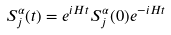Convert formula to latex. <formula><loc_0><loc_0><loc_500><loc_500>S ^ { \alpha } _ { j } ( t ) = e ^ { i H t } S ^ { \alpha } _ { j } ( 0 ) e ^ { - i H t }</formula> 